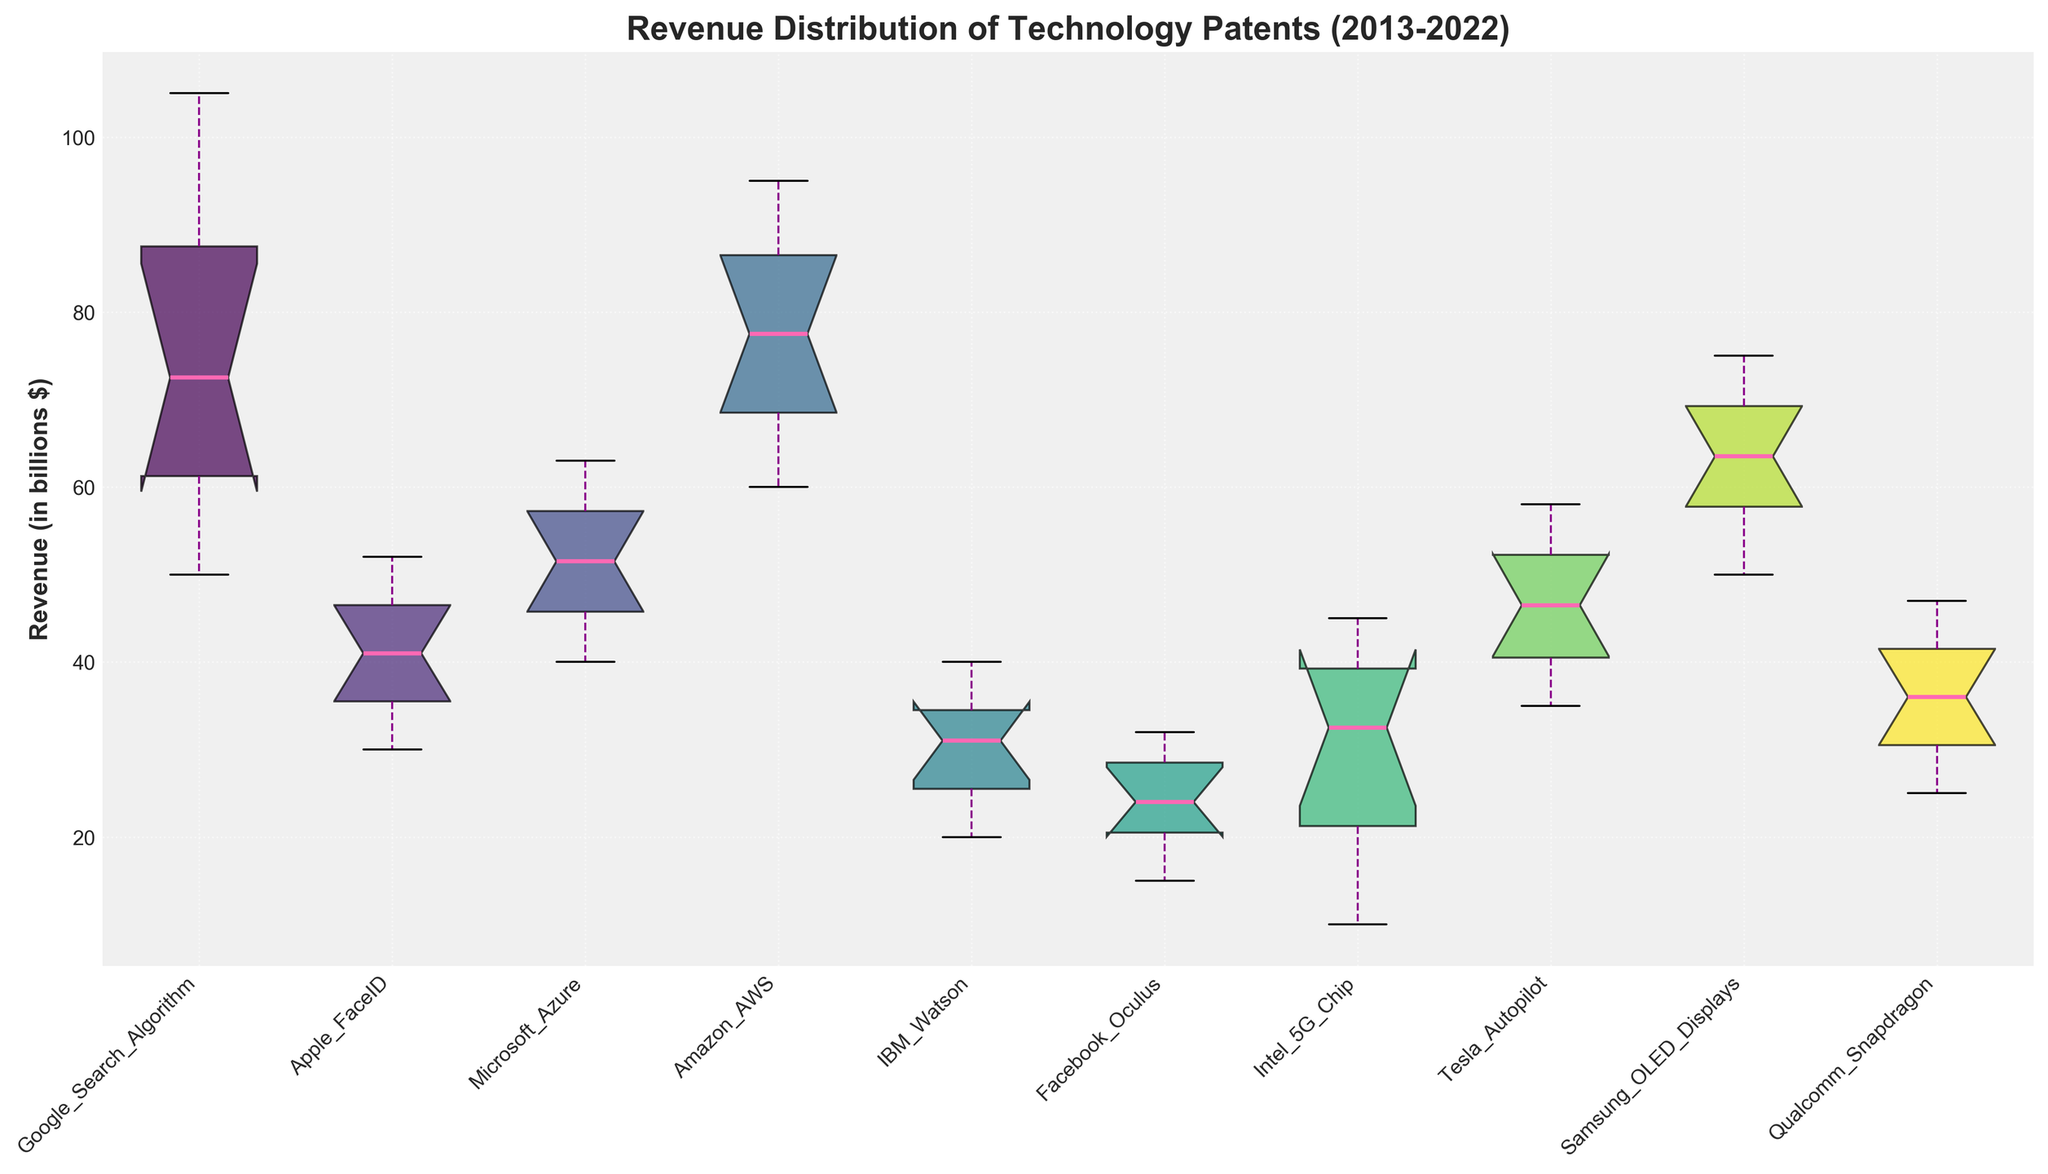Which technology patent has the highest average revenue? To find the highest average revenue, observe the central tendency of the box plots. The box plot with the highest median would typically have the highest average revenue, which here corresponds to the Google Search Algorithm.
Answer: Google Search Algorithm Which patent shows the widest distribution in revenue over the last decade? The widest distribution is indicated by the length of the box plot (interquartile range) along with the length of the whiskers. Amazon AWS shows the widest distribution.
Answer: Amazon AWS What is the median revenue of the Tesla Autopilot patent? The median is marked by the line inside the box of the box plot for Tesla Autopilot.
Answer: $48 billion Which patents have their median revenue above $50 billion? Look for the median lines inside the box plots that are above $50 billion. The patents are Google Search Algorithm, Amazon AWS, and Samsung OLED Displays.
Answer: Google Search Algorithm, Amazon AWS, Samsung OLED Displays How does the revenue distribution of Apple FaceID compare to IBM Watson? The box plot for Apple FaceID is consistently higher than IBM Watson, indicating higher revenues in each quartile. Apple FaceID also appears to have less variation than IBM Watson.
Answer: Apple FaceID has higher and less varied revenue distribution Which two patents have the closest median revenues? Find the patents whose median lines are close to each other within the box plots. Microsoft Azure and Samsung OLED Displays have very close median values.
Answer: Microsoft Azure and Samsung OLED Displays What is the minimum revenue recorded for the Google Search Algorithm patent? The minimum revenue is indicated by the bottom whisker of the Google Search Algorithm box plot.
Answer: $50 billion Are there any patents with outliers? Outliers are indicated by dots outside the whiskers of the box plots. The data does not show any outliers for any of the patents.
Answer: No Compare the first quartile revenue of Facebook Oculus with Qualcomm Snapdragon. The first quartile (bottom of the box) for Facebook Oculus is lower than that of Qualcomm Snapdragon.
Answer: Facebook Oculus is lower Which patent has the most consistent revenue over the decade in terms of least variation? Consistency is shown by the smallest box and the shortest whiskers. Apple FaceID exhibits the least variation.
Answer: Apple FaceID 